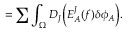Convert formula to latex. <formula><loc_0><loc_0><loc_500><loc_500>= \sum \int _ { \Omega } D _ { J } \left ( E _ { A } ^ { J } ( f ) \delta \phi _ { A } \right ) .</formula> 